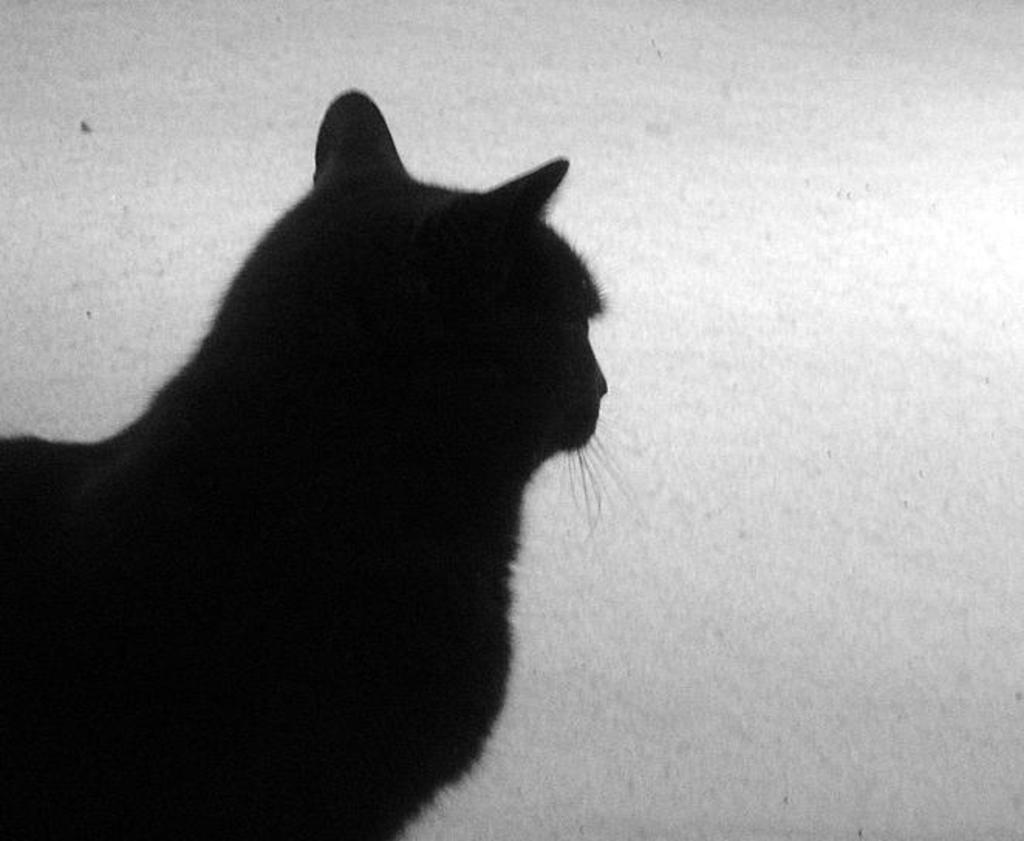What can be seen in the foreground of the image? There is a shadow of a cat in the foreground of the image. What surface does the shadow appear on? The shadow is on a wall. What suggestion does the cat make in the image? There is no suggestion made by the cat in the image, as it is only a shadow. 